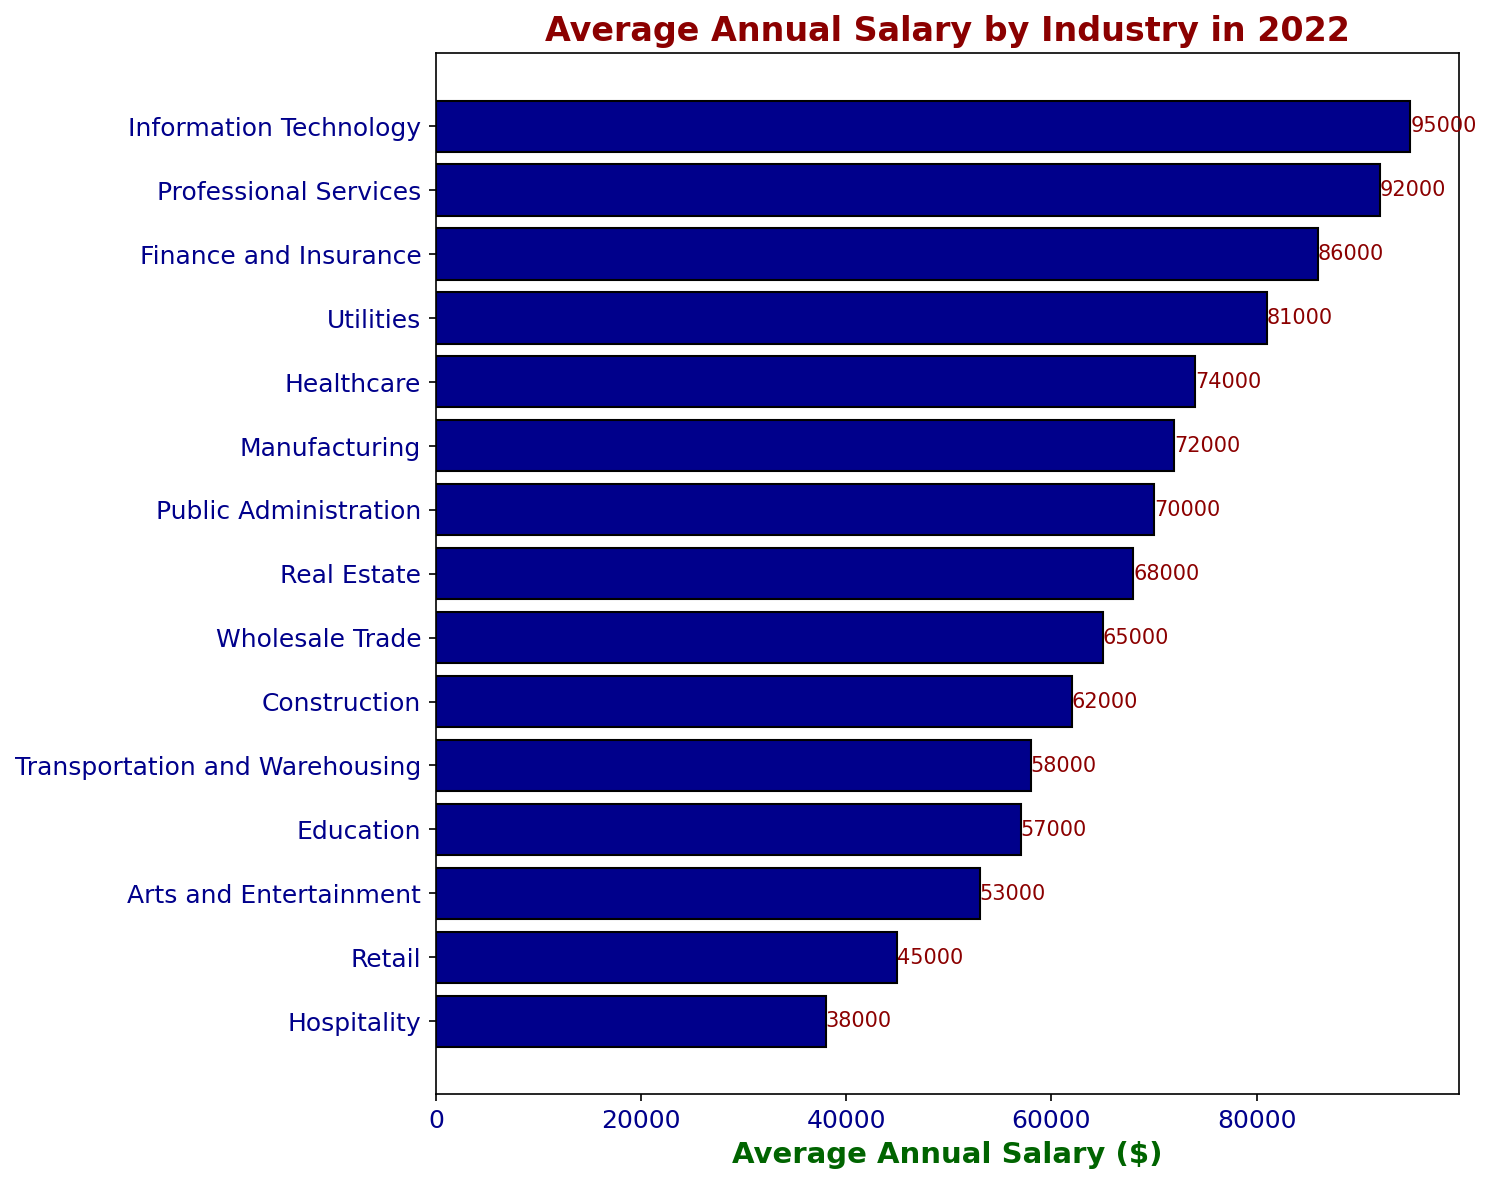What is the highest average annual salary by industry? The figure shows the average annual salary for each industry. The highest bar indicates that the Information Technology industry has the highest average annual salary.
Answer: Information Technology What is the lowest average annual salary by industry? The figure shows the average annual salary for each industry. The shortest bar represents the industry with the lowest average annual salary, which is Hospitality.
Answer: Hospitality How much higher is the average annual salary for Information Technology compared to Retail? Subtract the average annual salary of Retail ($45,000) from the average annual salary of Information Technology ($95,000) to find the difference.
Answer: $50,000 Which industry has an average annual salary closest to $60,000? By visually assessing the bars, the label for the Construction industry matches the closest to $60,000 with its salary being $62,000.
Answer: Construction How does the average annual salary in Education compare to Utilities? By comparing the bar lengths, Utilities has a higher average annual salary ($81,000) than Education ($57,000).
Answer: Utilities has a higher salary What's the total average annual salary for Healthcare, Manufacturing, and Public Administration? Add the average annual salaries: Healthcare ($74,000) + Manufacturing ($72,000) + Public Administration ($70,000). The total is 74,000 + 72,000 + 70,000.
Answer: $216,000 Which has a higher average annual salary: Transportation and Warehousing or Arts and Entertainment? Comparing the two bars visually, Transportation and Warehousing ($58,000) has a higher average annual salary than Arts and Entertainment ($53,000).
Answer: Transportation and Warehousing What is the difference in the average annual salary between Real Estate and Wholesale Trade? Subtract the average annual salary of Wholesale Trade ($65,000) from Real Estate ($68,000). The difference is 68,000 - 65,000.
Answer: $3,000 Is the average salary for Finance and Insurance higher or lower than Professional Services? Comparing the bar lengths shows that Professional Services ($92,000) has a higher average annual salary than Finance and Insurance ($86,000).
Answer: Lower Which industry has an average annual salary just $10,000 more than Education? Finding bars $10,000 more than Education’s ($57,000) leads to Transportation and Warehousing ($58,000) and Real Estate ($68,000). Thus, Real Estate is $10,000 more.
Answer: Real Estate 